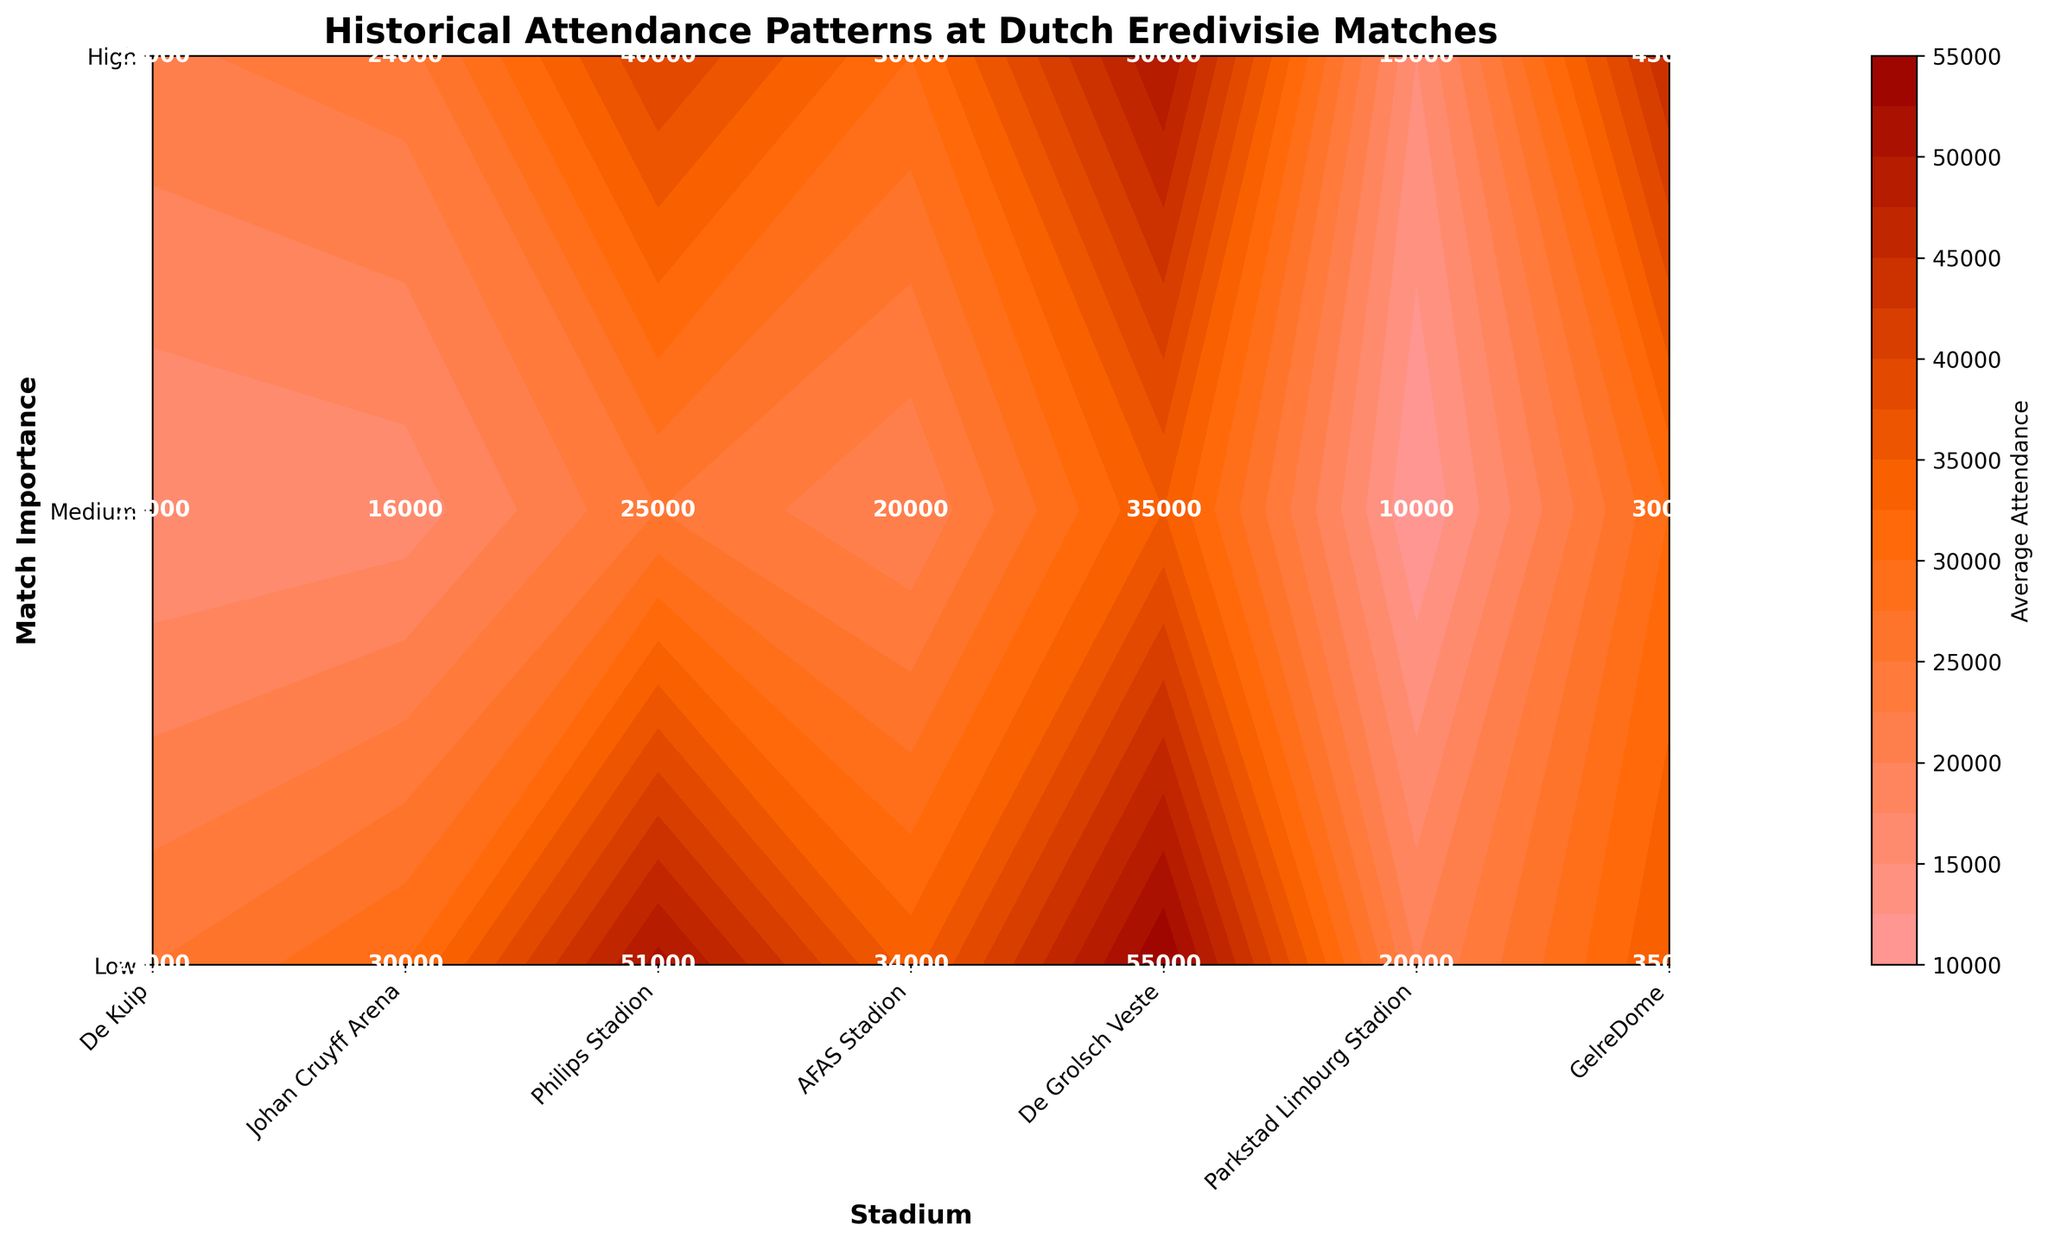What is the title of the plot? The title of the plot is displayed at the top of the figure in a bold font and reads "Historical Attendance Patterns at Dutch Eredivisie Matches".
Answer: Historical Attendance Patterns at Dutch Eredivisie Matches Which stadium has the highest average attendance for high importance matches? By looking at the "High" match importance row, the highest value is at the Johan Cruyff Arena with an average attendance of 55,000.
Answer: Johan Cruyff Arena What are the y-axis labels? The y-axis labels correspond to match importance levels and can be found on the side of the plot. They are "Low", "Medium", and "High".
Answer: Low, Medium, High What is the average attendance for low importance matches at De Kuip? Locate the "Low" row for match importance, and then find the value under the De Kuip column, which is 25,000.
Answer: 25,000 Compare the average attendance between Johan Cruyff Arena and Philips Stadion for medium importance matches. Which is higher? By how much? For medium importance matches, Johan Cruyff Arena has an average attendance of 50,000, while Philips Stadion has 45,000. So, Johan Cruyff Arena's average attendance is higher by 5,000.
Answer: Johan Cruyff Arena, by 5,000 Which stadium has the lowest average attendance for low importance matches? In the "Low" importance row, the lowest value is at Parkstad Limburg Stadion with an average attendance of 10,000.
Answer: Parkstad Limburg Stadion What is the difference in average attendance between high and low importance matches at AFAS Stadion? The average attendance for high importance matches at AFAS Stadion is 25,000, and for low importance matches, it is 15,000. The difference is 25,000 - 15,000 = 10,000.
Answer: 10,000 Which two stadiums have the same average attendance for high importance matches? Both Johan Cruyff Arena and Philips Stadion have different values for high importance matches as Johan Cruyff Arena has 55,000 and Philips Stadion has 35,000, but De Kuip and Johan Cruyff Arena have similar values of 51,000 and 55,000 respectively. Alternatively, look at their exact numeric values.
Answer: None Explain how the color gradient helps interpret the figure. The color gradient in the contour plot ranges from light to dark, indicating increasing average attendance. Lighter colors represent lower attendance while darker colors indicate higher attendance. This helps quickly identify trends and patterns, such as which stadiums have higher attendance for different match importance levels.
Answer: Gradient from light to dark reveals attendance levels 